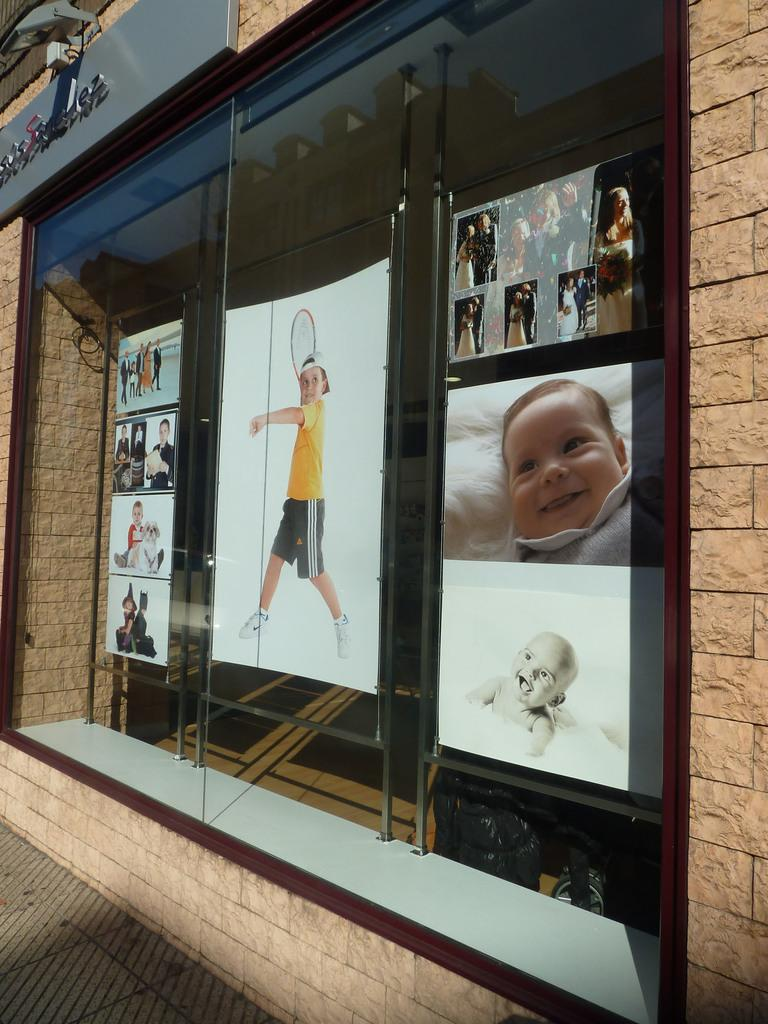What is displayed on the glass window in the image? There are photographs of different kids in the image. Where is the glass window located? The glass window is on a wall. How does the rain affect the photographs on the glass window in the image? There is no rain present in the image, so its effect on the photographs cannot be determined. 